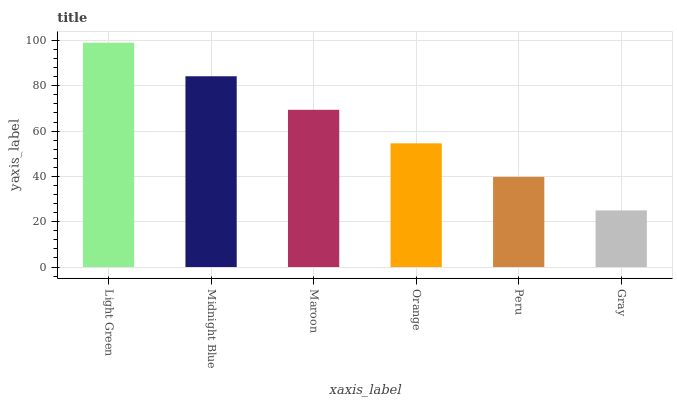Is Gray the minimum?
Answer yes or no. Yes. Is Light Green the maximum?
Answer yes or no. Yes. Is Midnight Blue the minimum?
Answer yes or no. No. Is Midnight Blue the maximum?
Answer yes or no. No. Is Light Green greater than Midnight Blue?
Answer yes or no. Yes. Is Midnight Blue less than Light Green?
Answer yes or no. Yes. Is Midnight Blue greater than Light Green?
Answer yes or no. No. Is Light Green less than Midnight Blue?
Answer yes or no. No. Is Maroon the high median?
Answer yes or no. Yes. Is Orange the low median?
Answer yes or no. Yes. Is Midnight Blue the high median?
Answer yes or no. No. Is Gray the low median?
Answer yes or no. No. 